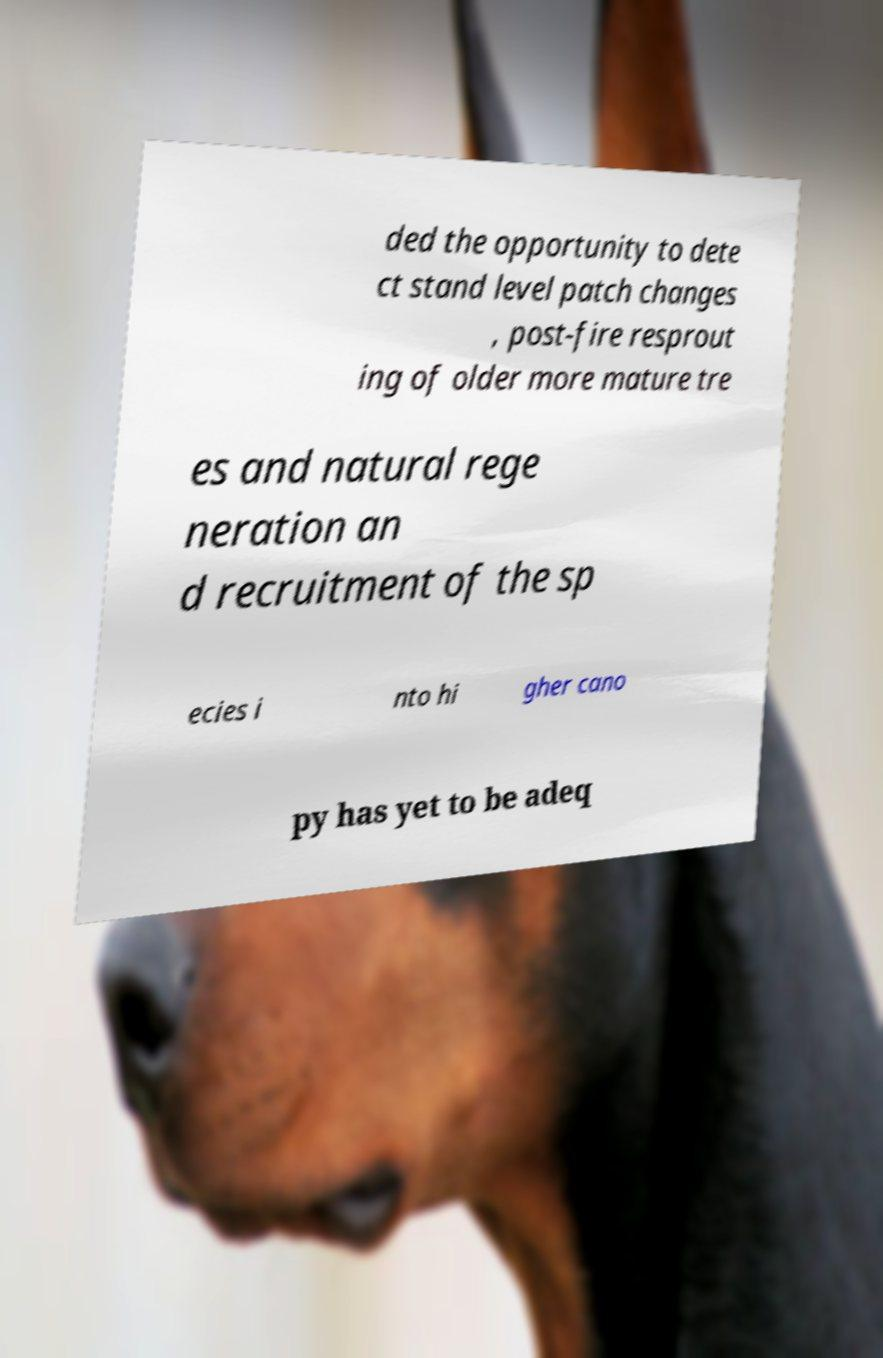Please identify and transcribe the text found in this image. ded the opportunity to dete ct stand level patch changes , post-fire resprout ing of older more mature tre es and natural rege neration an d recruitment of the sp ecies i nto hi gher cano py has yet to be adeq 